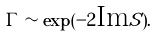<formula> <loc_0><loc_0><loc_500><loc_500>\Gamma \sim \exp ( - 2 \text {Im} S ) .</formula> 